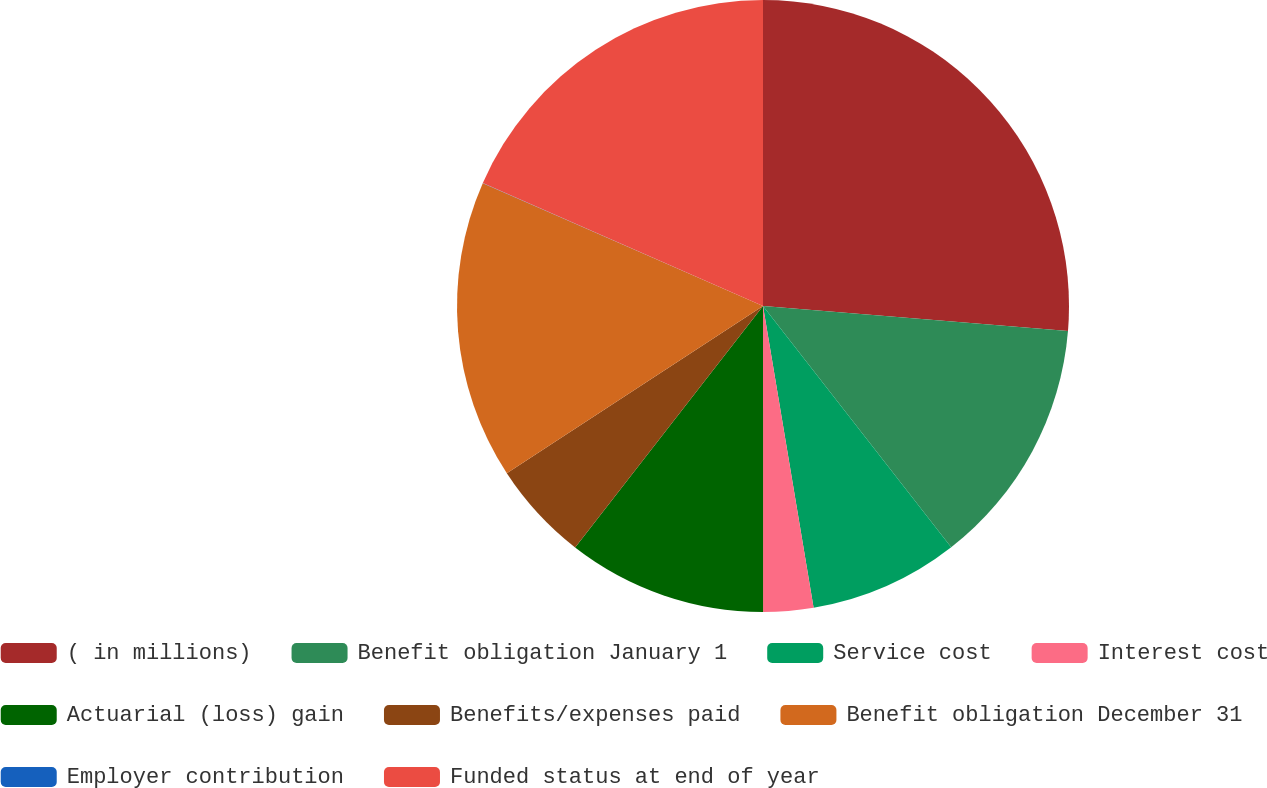Convert chart. <chart><loc_0><loc_0><loc_500><loc_500><pie_chart><fcel>( in millions)<fcel>Benefit obligation January 1<fcel>Service cost<fcel>Interest cost<fcel>Actuarial (loss) gain<fcel>Benefits/expenses paid<fcel>Benefit obligation December 31<fcel>Employer contribution<fcel>Funded status at end of year<nl><fcel>26.31%<fcel>13.16%<fcel>7.9%<fcel>2.64%<fcel>10.53%<fcel>5.27%<fcel>15.79%<fcel>0.01%<fcel>18.42%<nl></chart> 